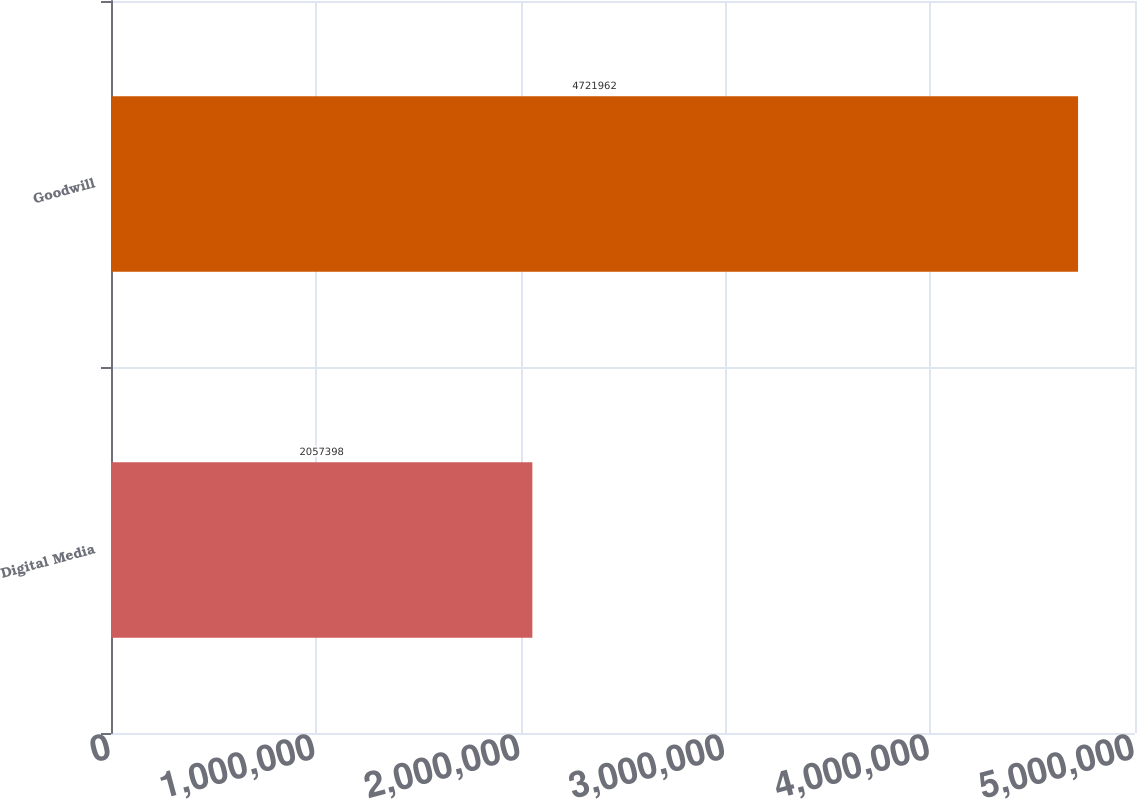Convert chart. <chart><loc_0><loc_0><loc_500><loc_500><bar_chart><fcel>Digital Media<fcel>Goodwill<nl><fcel>2.0574e+06<fcel>4.72196e+06<nl></chart> 